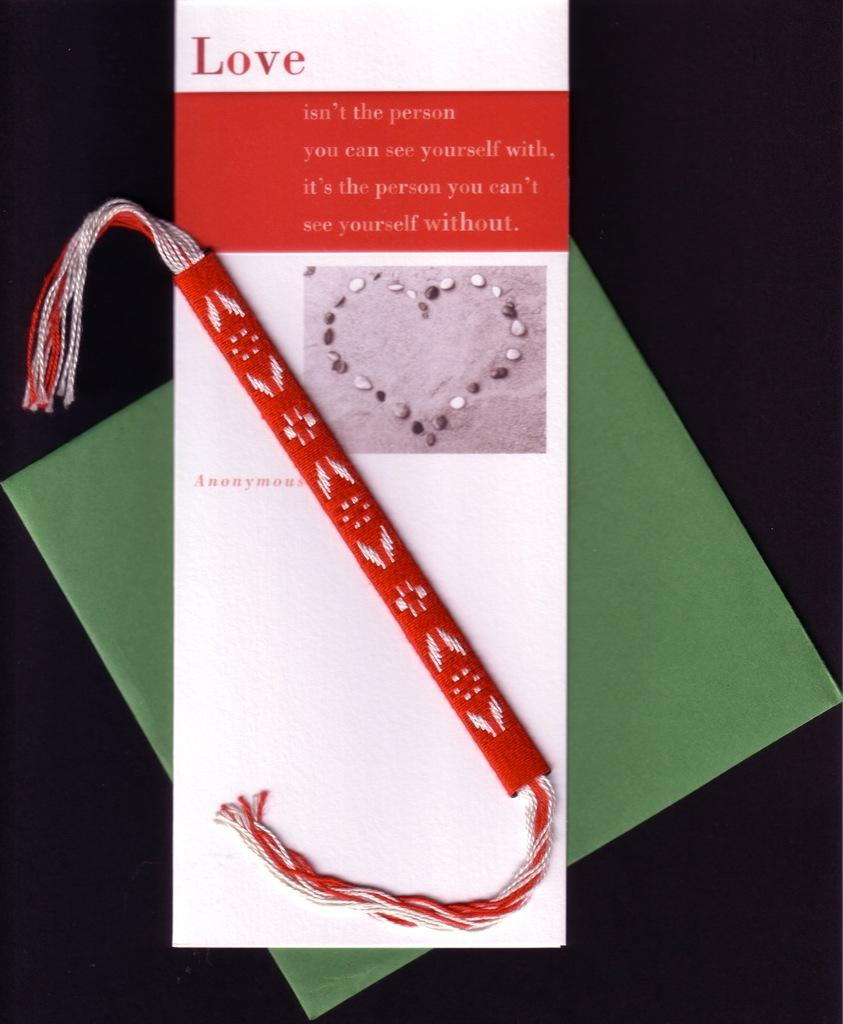Provide a one-sentence caption for the provided image. A bracelet is on top of a card that discusses love. 